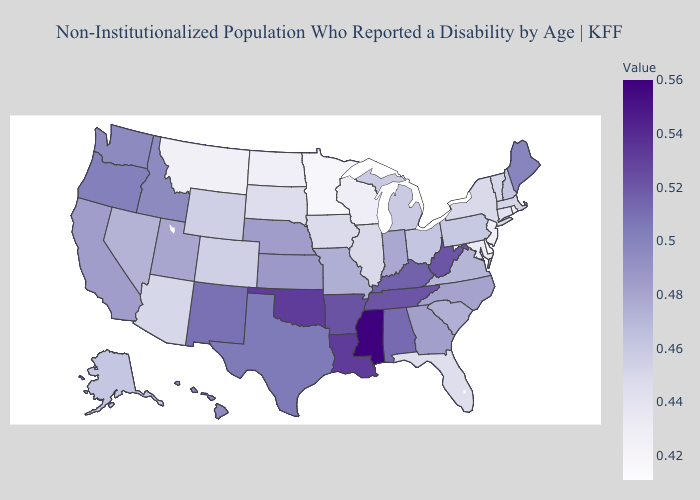Does the map have missing data?
Short answer required. No. Among the states that border Montana , which have the lowest value?
Keep it brief. North Dakota. Among the states that border California , which have the lowest value?
Write a very short answer. Arizona. Which states have the lowest value in the Northeast?
Be succinct. Rhode Island. 